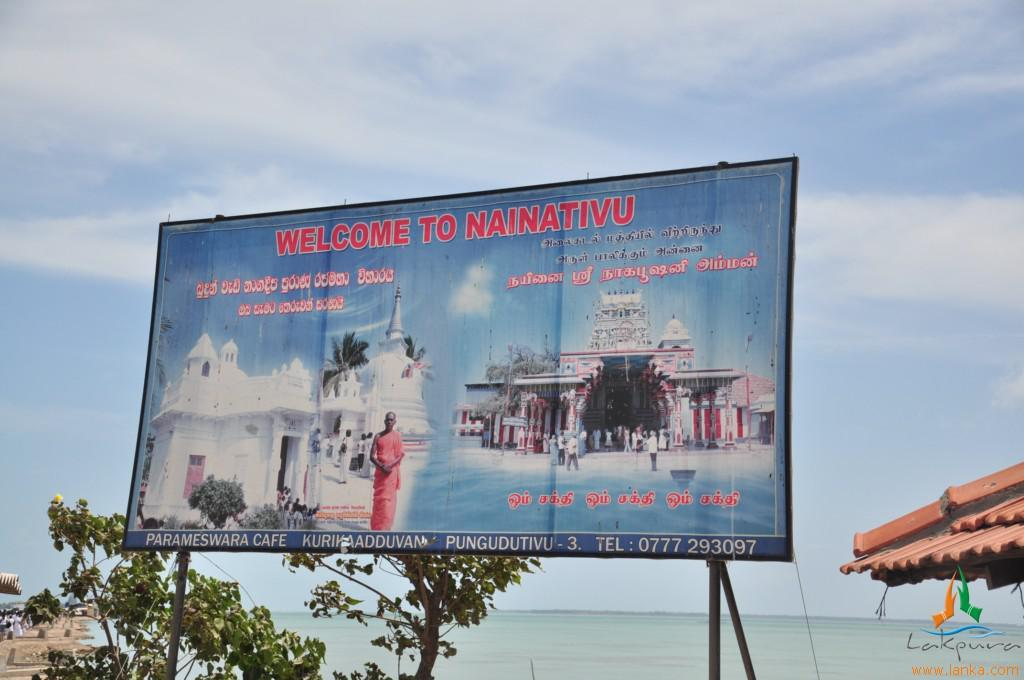<image>
Share a concise interpretation of the image provided. A worn sign that says welcom to nainativu in a large red font. 